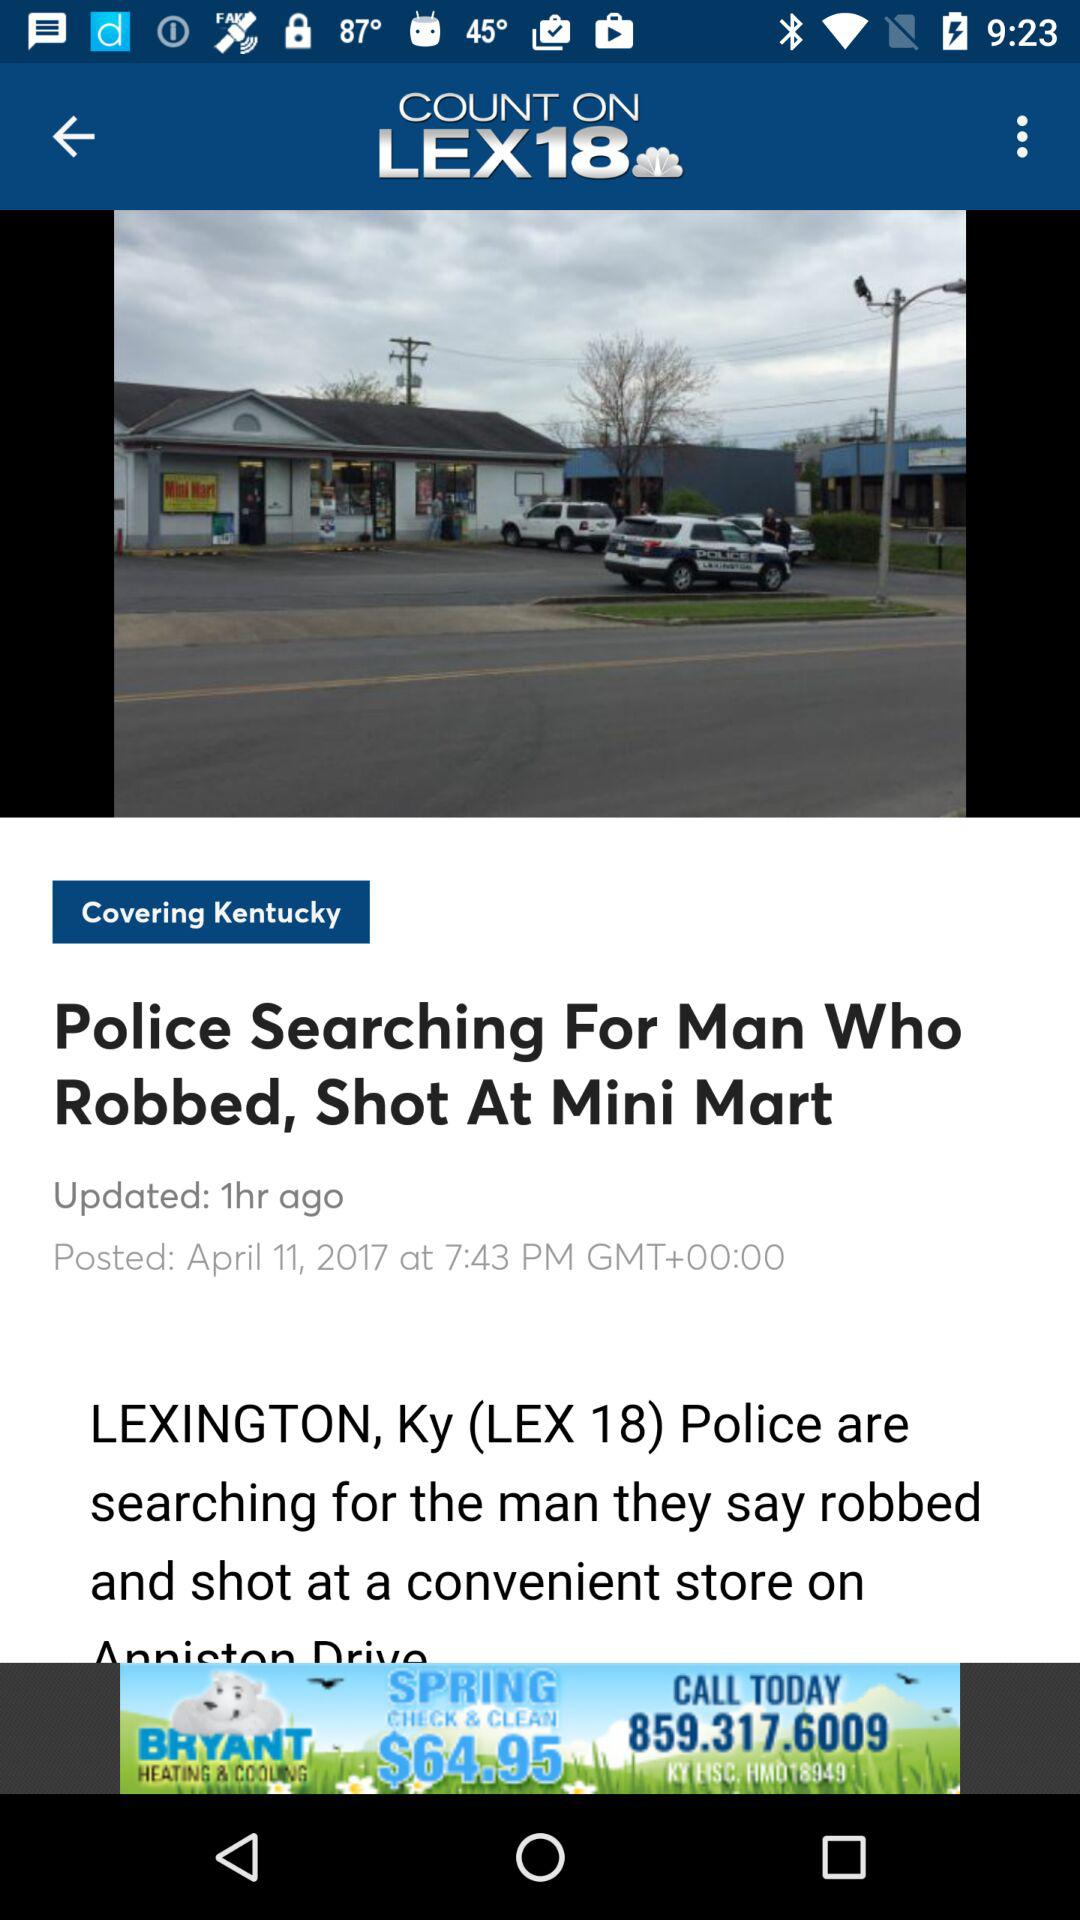When was the article updated? The article was last updated 1 hour ago. 